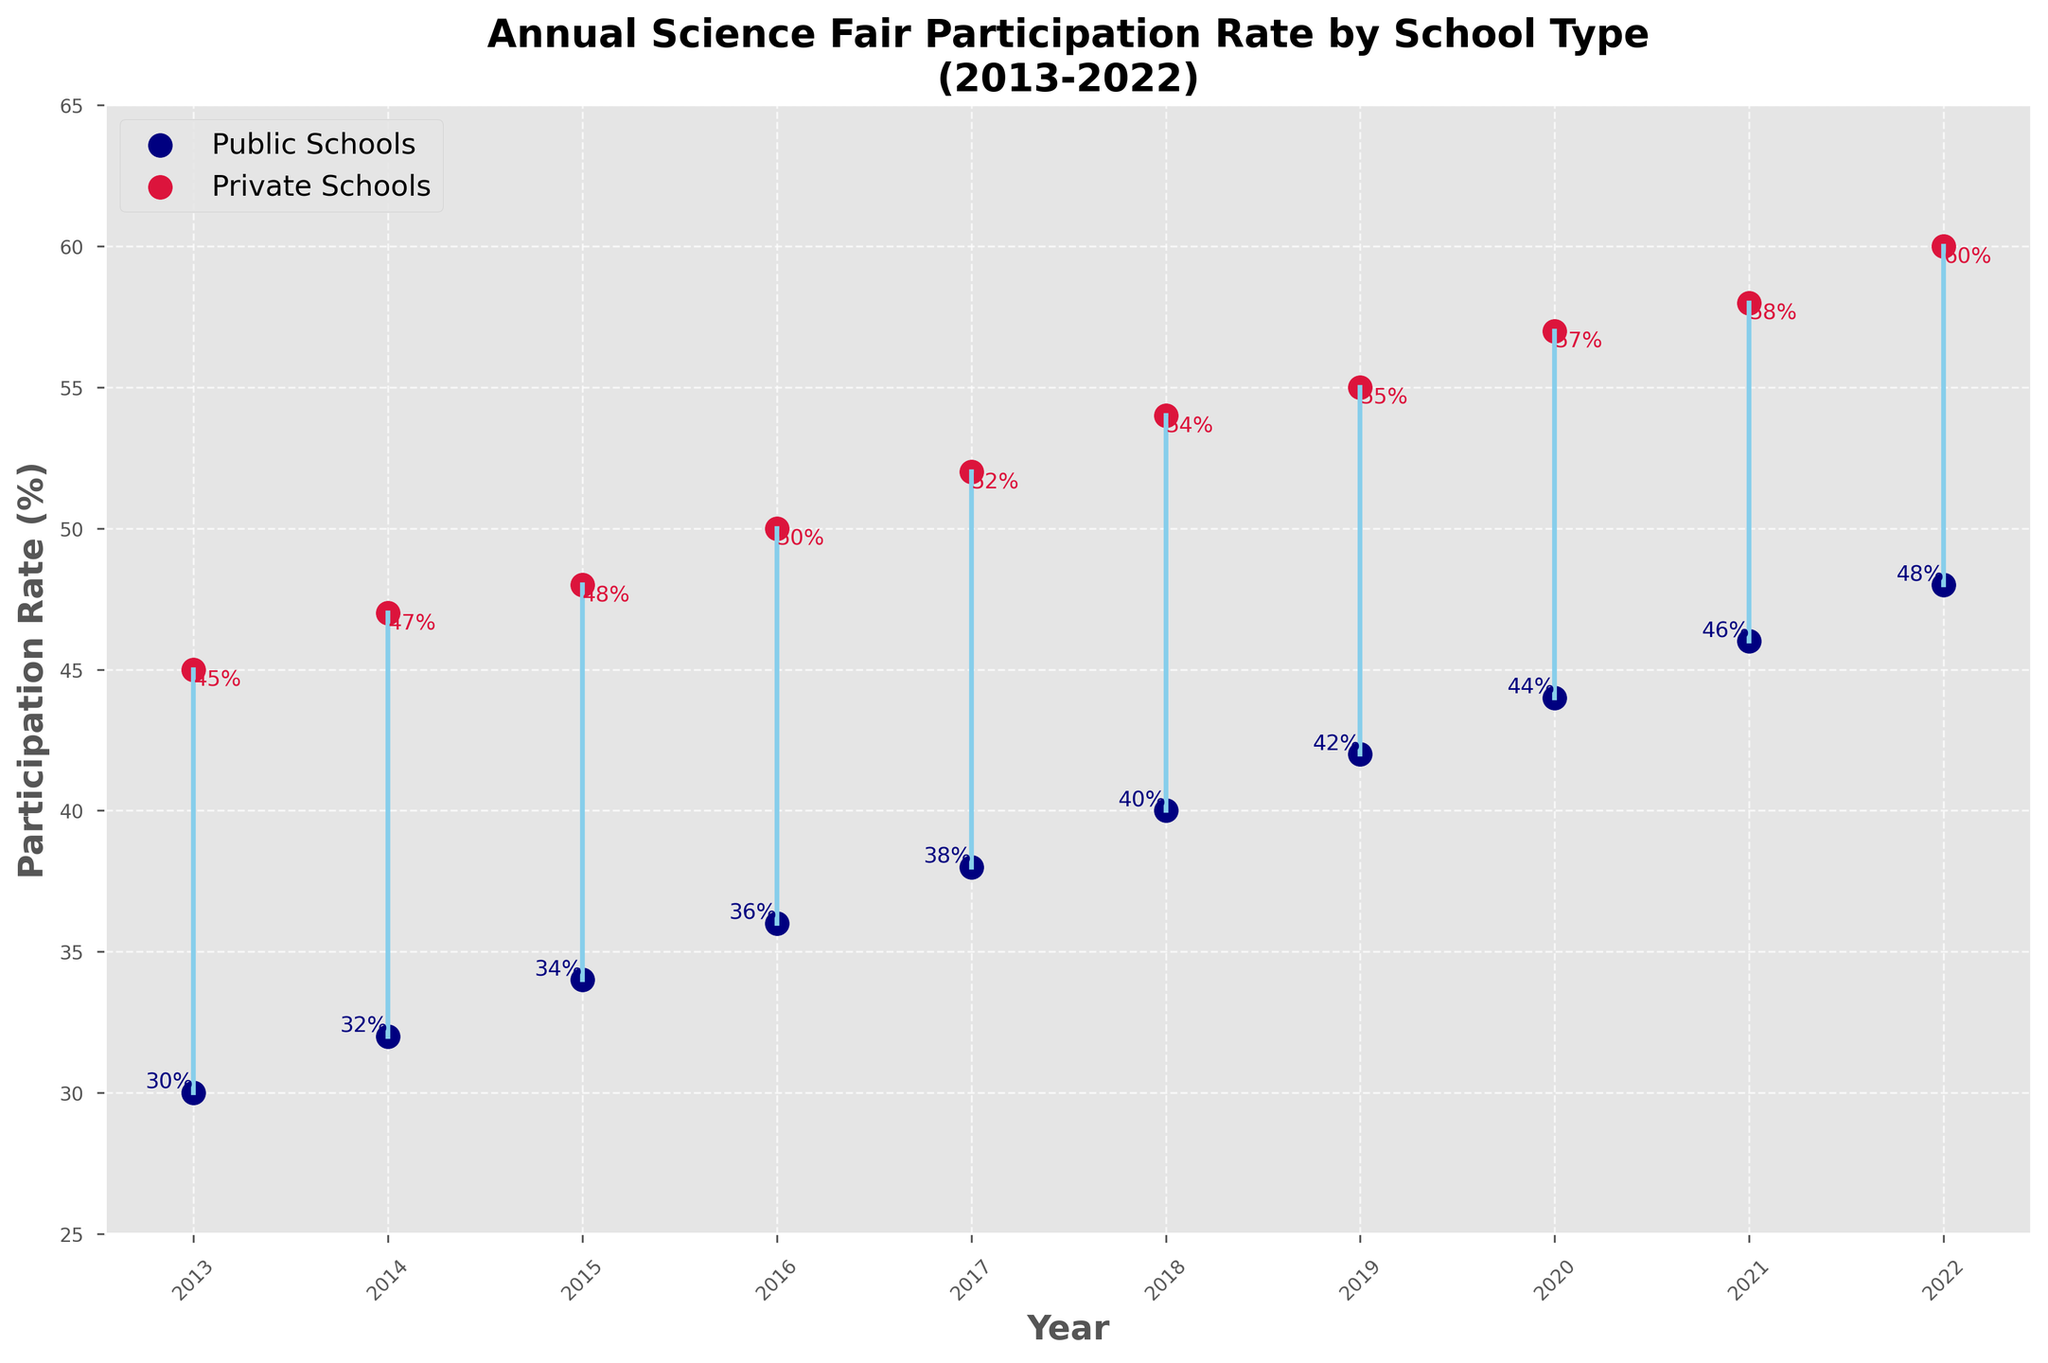what is the title of the plot? The title of a plot is typically located at the top and indicates the subject and time frame of the data being presented. In this case, it shows "Annual Science Fair Participation Rate by School Type" and mentions the years 2013-2022.
Answer: Annual Science Fair Participation Rate by School Type (2013-2022) How many years does the plot cover? To find the number of years covered, count the unique years displayed along the x-axis. According to the data, the years range from 2013 to 2022.
Answer: 10 years What is the participation rate for public schools in the year 2017? Look at the data points for public schools, indicated by blue dots, and check the value that corresponds to the year 2017.
Answer: 38% Which school type had a higher participation rate in 2014? Compare the data points for both public (blue dot) and private (red dot) schools for the year 2014. The private school's participation rate is higher than the public school's.
Answer: Private Schools What is the average participation rate for private schools over the decade? Add up all the participation rates for private schools (45, 47, 48, 50, 52, 54, 55, 57, 58, 60), and then divide by the number of years (10). (45+47+48+50+52+54+55+57+58+60) = 526, so the average is 526/10 = 52.6
Answer: 52.6% What is the trend in participation rates for public schools from 2013 to 2022? Look at the progression of the blue dots from 2013 to 2022 to see if it is increasing, decreasing, or remaining constant. The blue dots show an upward trend.
Answer: Increasing By how much did the participation rate for private schools increase from 2013 to 2022? Subtract the 2013 participation rate for private schools (45%) from the 2022 rate (60%). 60% - 45% = 15%
Answer: 15% What is the difference in participation rates between public and private schools in 2020? Find the participation rate for both public (44%) and private (57%) schools for the year 2020, then subtract the public rate from the private rate. 57% - 44% = 13%
Answer: 13% In which year was the smallest gap in participation rates between public and private schools? Calculate the difference between public and private school participation rates for each year. Identify the year with the smallest difference by comparing these values. The smallest gap is in 2015: 48% - 34% = 14%.
Answer: 2015 